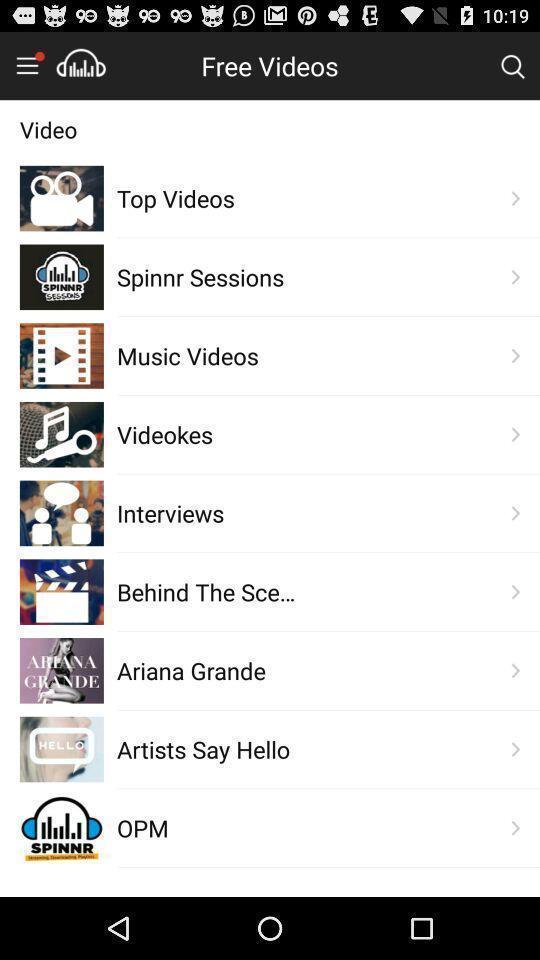Provide a textual representation of this image. Screen shows free videos. 